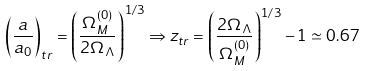Convert formula to latex. <formula><loc_0><loc_0><loc_500><loc_500>\left ( \frac { a } { a _ { 0 } } \right ) _ { t r } = \left ( \frac { \Omega _ { M } ^ { ( 0 ) } } { 2 \Omega _ { \Lambda } } \right ) ^ { 1 / 3 } \Rightarrow z _ { t r } = \left ( \frac { 2 \Omega _ { \Lambda } } { \Omega _ { M } ^ { ( 0 ) } } \right ) ^ { 1 / 3 } - 1 \simeq 0 . 6 7</formula> 